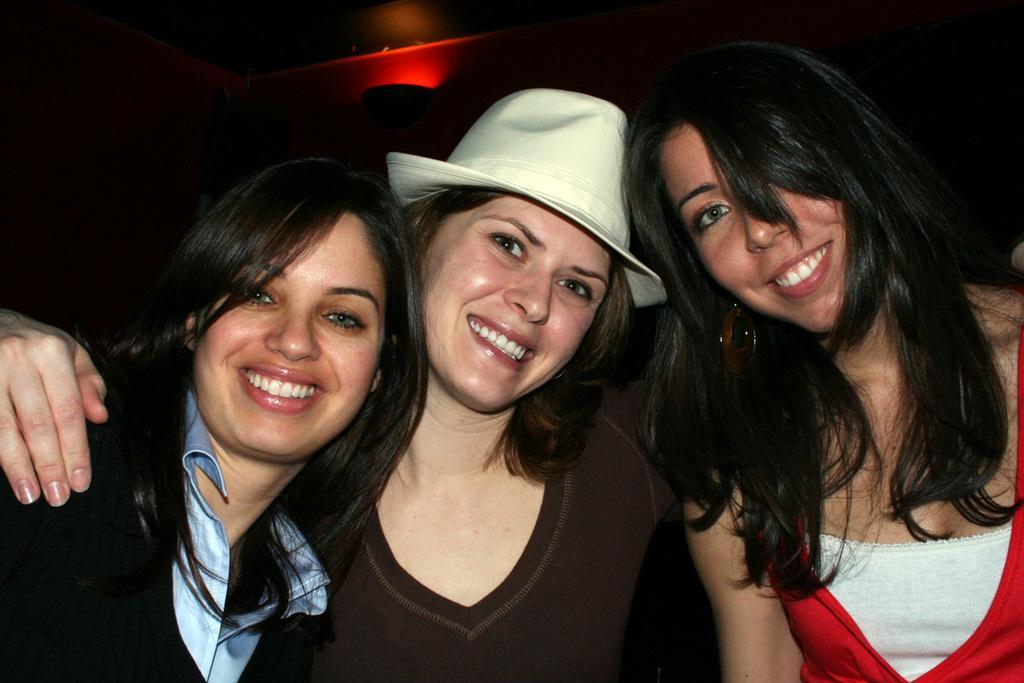How would you summarize this image in a sentence or two? In this image in front there are three people wearing a smile on their faces. Behind them there is light. 